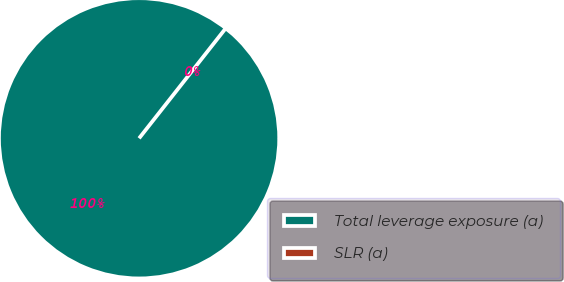Convert chart to OTSL. <chart><loc_0><loc_0><loc_500><loc_500><pie_chart><fcel>Total leverage exposure (a)<fcel>SLR (a)<nl><fcel>100.0%<fcel>0.0%<nl></chart> 